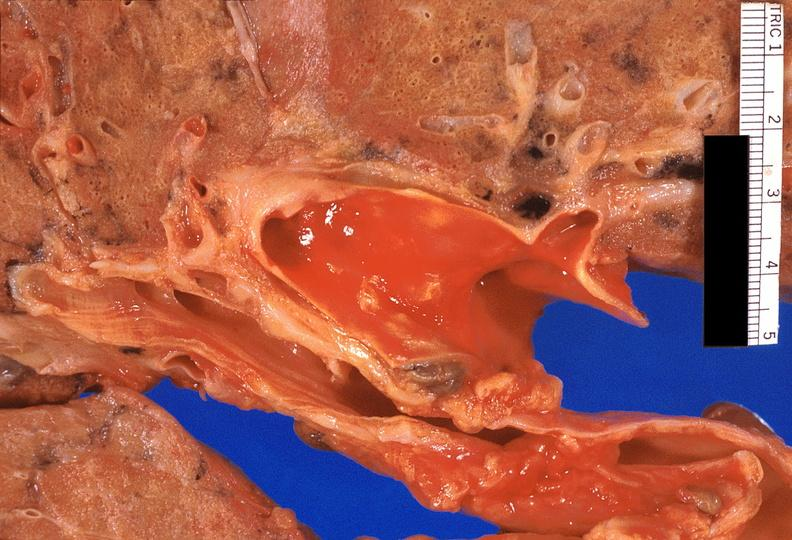what does this image show?
Answer the question using a single word or phrase. Lung 